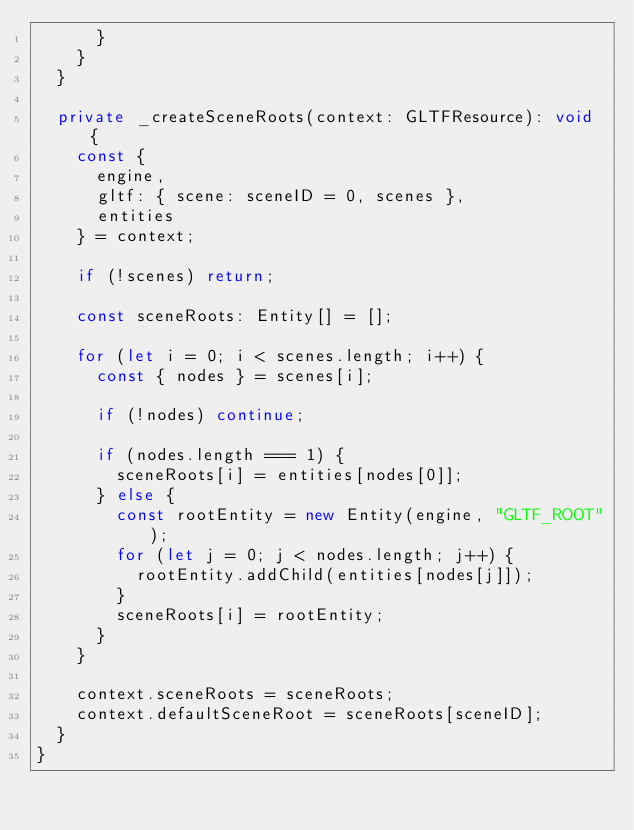<code> <loc_0><loc_0><loc_500><loc_500><_TypeScript_>      }
    }
  }

  private _createSceneRoots(context: GLTFResource): void {
    const {
      engine,
      gltf: { scene: sceneID = 0, scenes },
      entities
    } = context;

    if (!scenes) return;

    const sceneRoots: Entity[] = [];

    for (let i = 0; i < scenes.length; i++) {
      const { nodes } = scenes[i];

      if (!nodes) continue;

      if (nodes.length === 1) {
        sceneRoots[i] = entities[nodes[0]];
      } else {
        const rootEntity = new Entity(engine, "GLTF_ROOT");
        for (let j = 0; j < nodes.length; j++) {
          rootEntity.addChild(entities[nodes[j]]);
        }
        sceneRoots[i] = rootEntity;
      }
    }

    context.sceneRoots = sceneRoots;
    context.defaultSceneRoot = sceneRoots[sceneID];
  }
}
</code> 